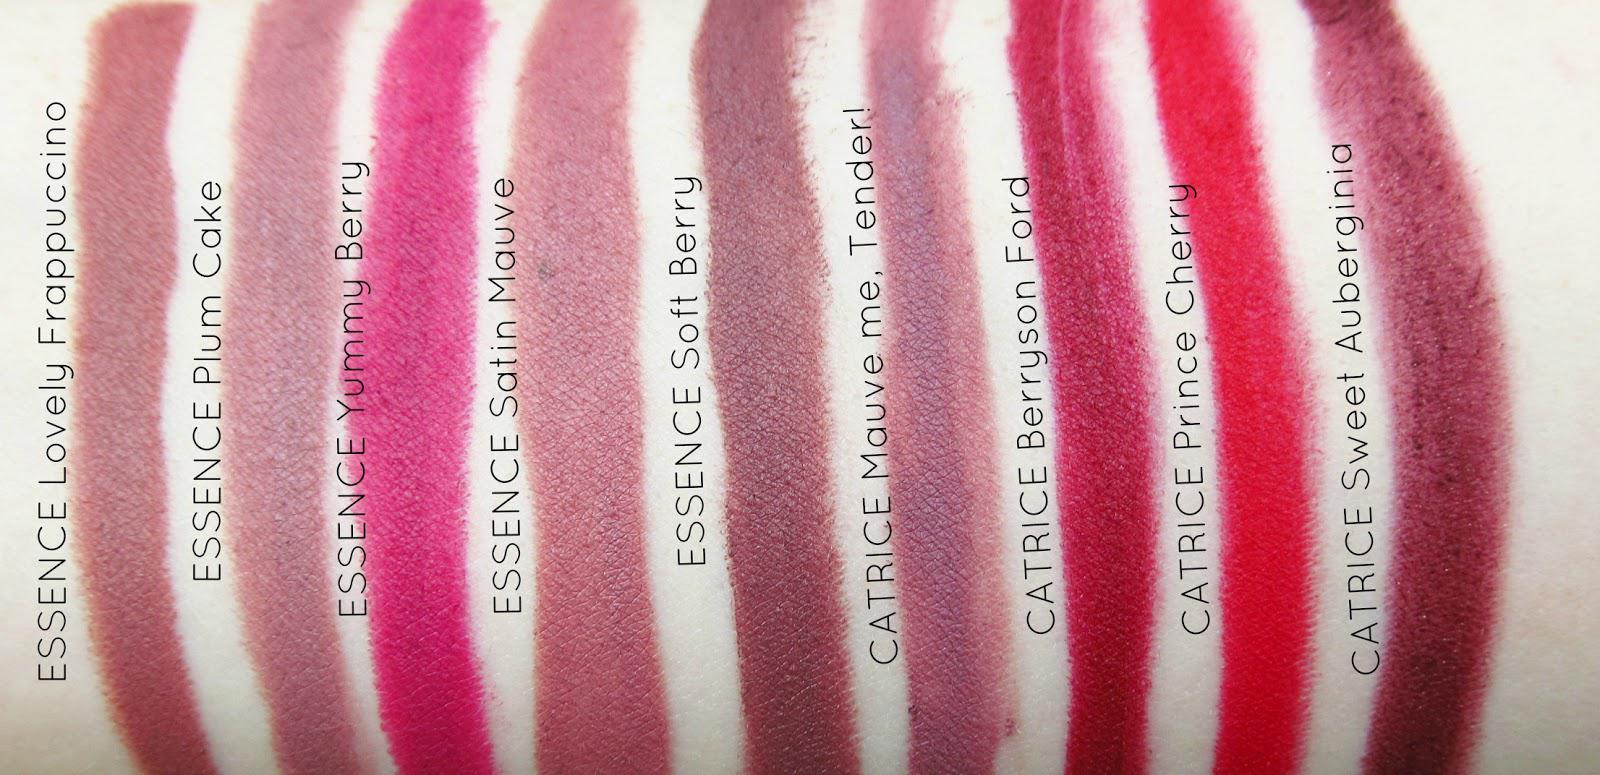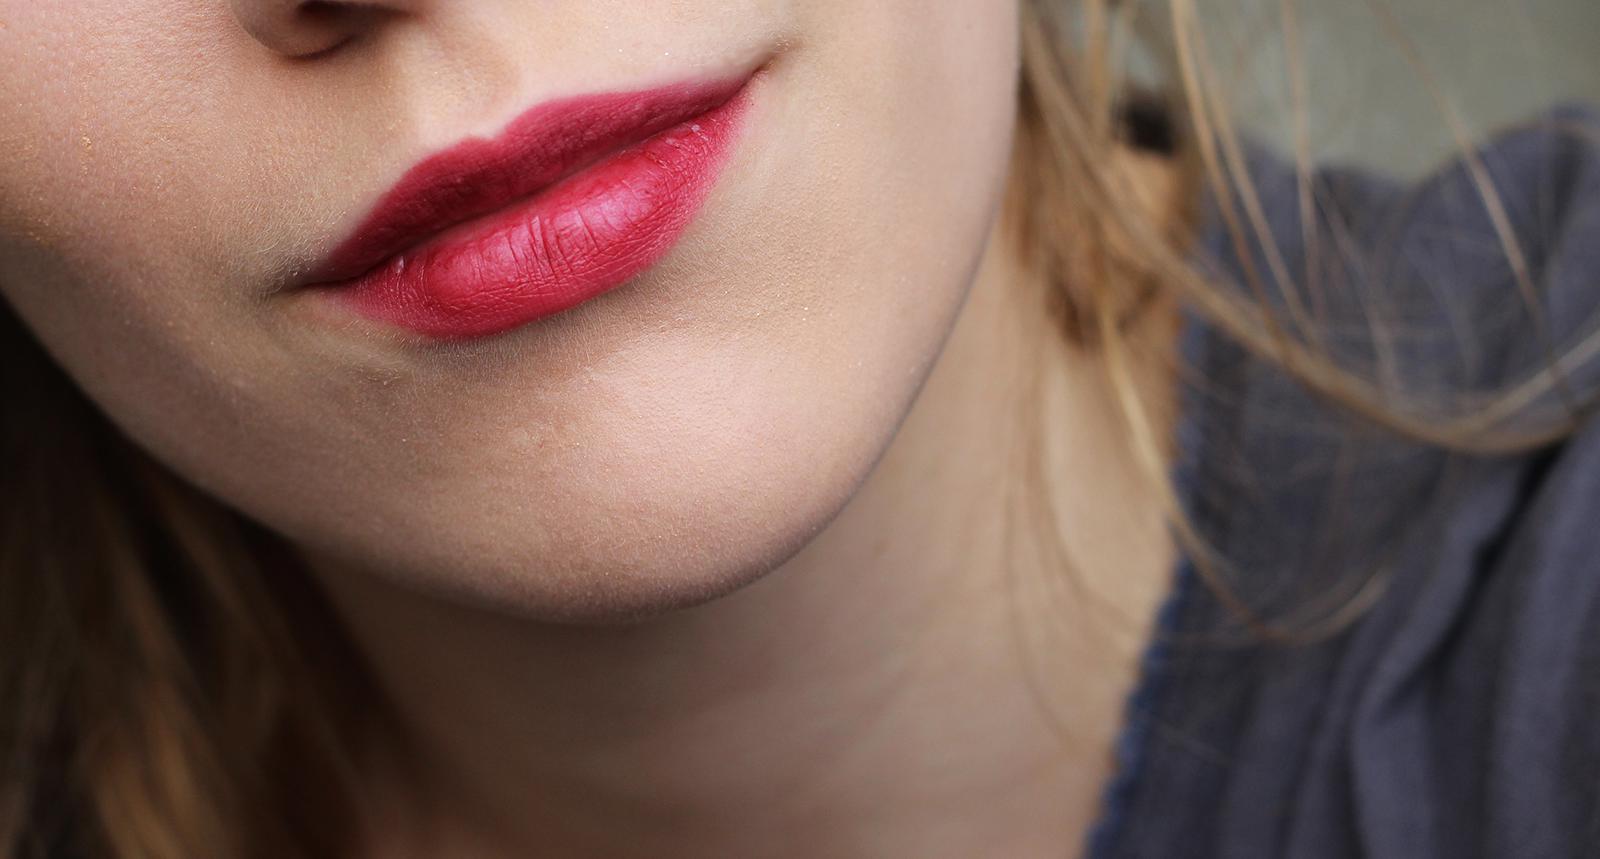The first image is the image on the left, the second image is the image on the right. For the images shown, is this caption "There is a woman wearing lipstick on the right image and swatches of lip products on the left." true? Answer yes or no. Yes. The first image is the image on the left, the second image is the image on the right. Given the left and right images, does the statement "One image includes multiple deep-red painted fingernails, and at least one image includes tinted lips." hold true? Answer yes or no. No. 